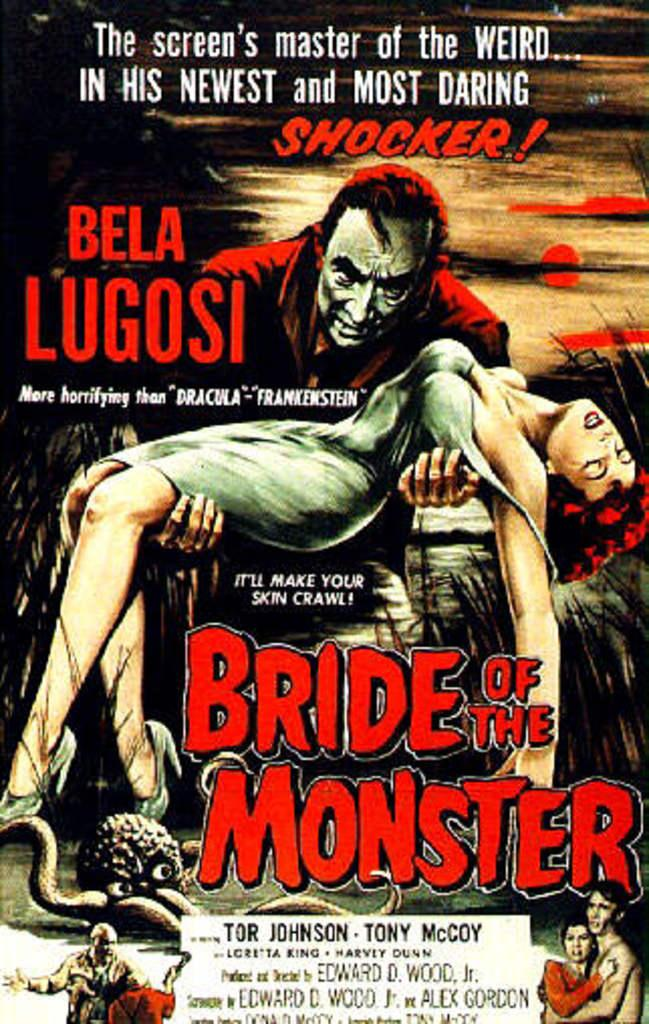What is the main subject in the center of the image? There is a poster in the center of the image. What can be read on the poster? The words "bride of the monster" are written on the poster. How many birds are flying over the sign in the image? There is no sign or birds present in the image; it only features a poster with the words "bride of the monster." 